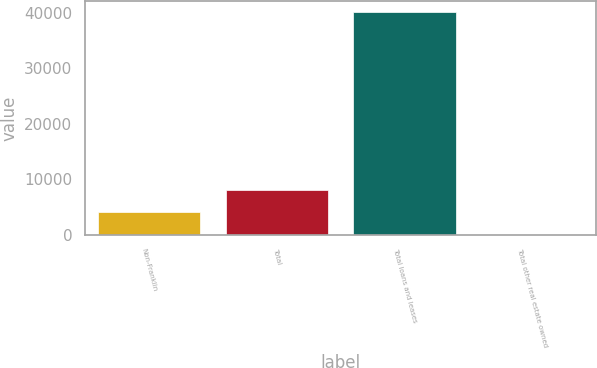Convert chart to OTSL. <chart><loc_0><loc_0><loc_500><loc_500><bar_chart><fcel>Non-Franklin<fcel>Total<fcel>Total loans and leases<fcel>Total other real estate owned<nl><fcel>4073.2<fcel>8071.1<fcel>40054.3<fcel>75.3<nl></chart> 